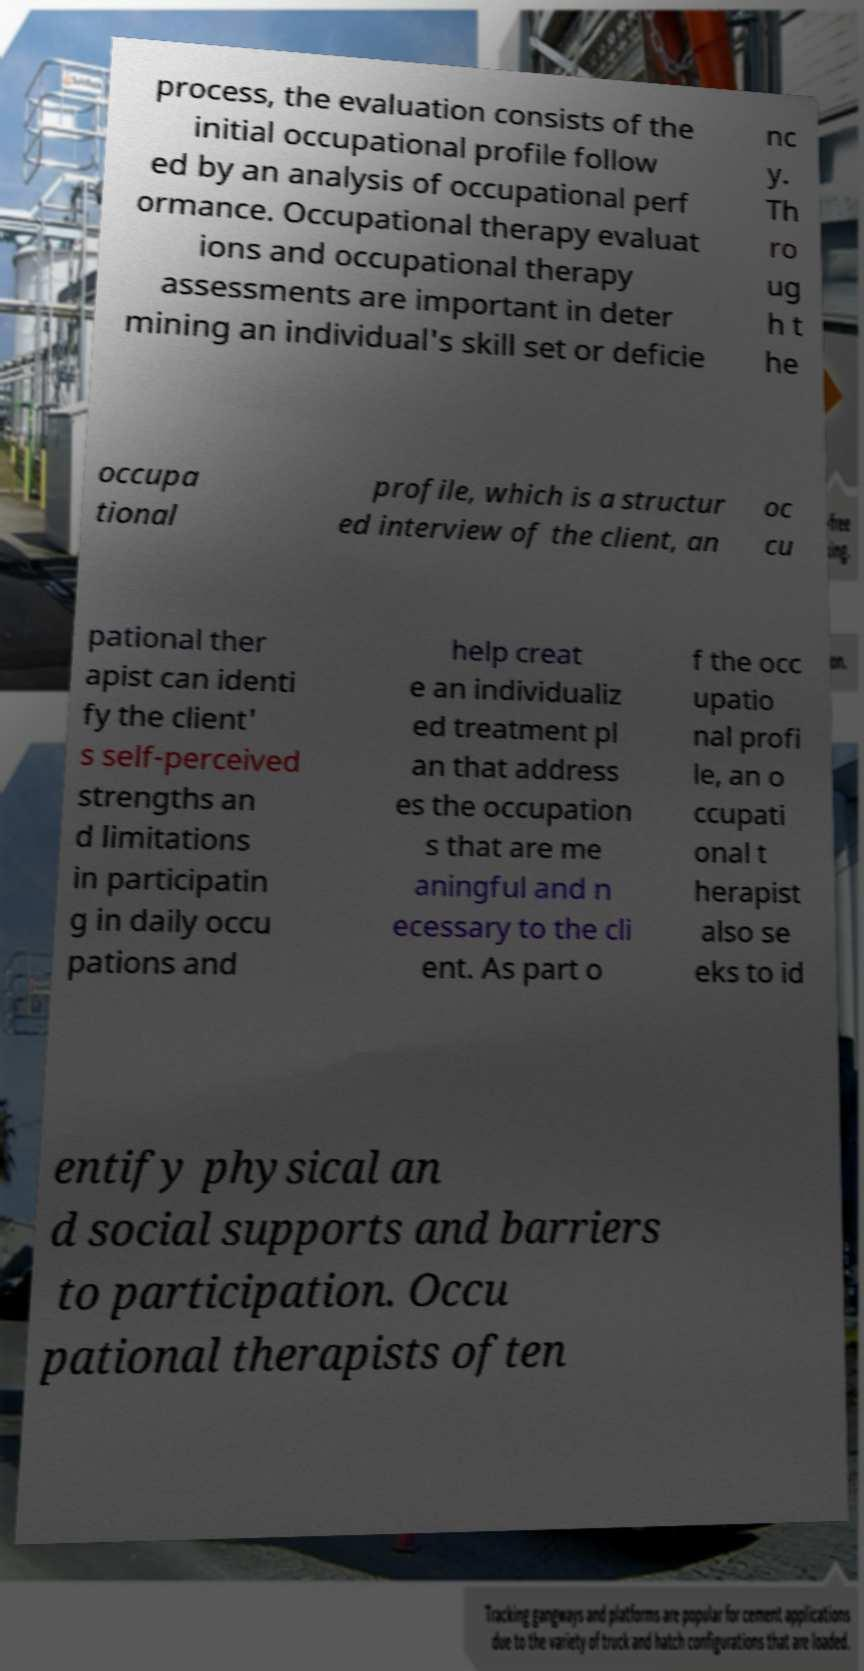There's text embedded in this image that I need extracted. Can you transcribe it verbatim? process, the evaluation consists of the initial occupational profile follow ed by an analysis of occupational perf ormance. Occupational therapy evaluat ions and occupational therapy assessments are important in deter mining an individual's skill set or deficie nc y. Th ro ug h t he occupa tional profile, which is a structur ed interview of the client, an oc cu pational ther apist can identi fy the client' s self-perceived strengths an d limitations in participatin g in daily occu pations and help creat e an individualiz ed treatment pl an that address es the occupation s that are me aningful and n ecessary to the cli ent. As part o f the occ upatio nal profi le, an o ccupati onal t herapist also se eks to id entify physical an d social supports and barriers to participation. Occu pational therapists often 